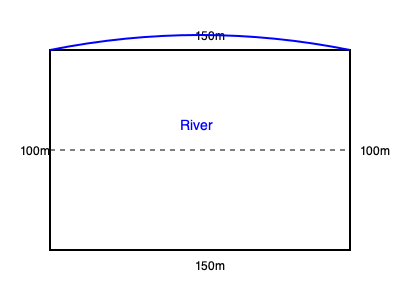Based on the aerial view diagram of your field, which is roughly rectangular but has a curved river along one side, estimate the total cultivable area in hectares. The field measures 150m on two sides and 100m on the other two sides. How does the river's presence affect your estimate? To estimate the cultivable area, let's follow these steps:

1. Calculate the total area of the rectangular field:
   Area = length × width
   $$ A = 150\text{ m} \times 100\text{ m} = 15,000\text{ m}^2 $$

2. Convert square meters to hectares:
   $$ 15,000\text{ m}^2 = 1.5\text{ hectares} $$

3. Estimate the area taken by the river:
   The river curves into the field, reducing the cultivable area. It appears to take up roughly 10% of the total area.

4. Calculate the estimated cultivable area:
   $$ 1.5\text{ hectares} - (10\% \times 1.5\text{ hectares}) = 1.5\text{ hectares} - 0.15\text{ hectares} = 1.35\text{ hectares} $$

5. Round to a practical measure for farming purposes:
   $$ 1.35\text{ hectares} \approx 1.3\text{ hectares} $$

The river's presence reduces the cultivable area by approximately 0.2 hectares, which is significant for a small farm and should be considered when planning crops and estimating yields.
Answer: 1.3 hectares 